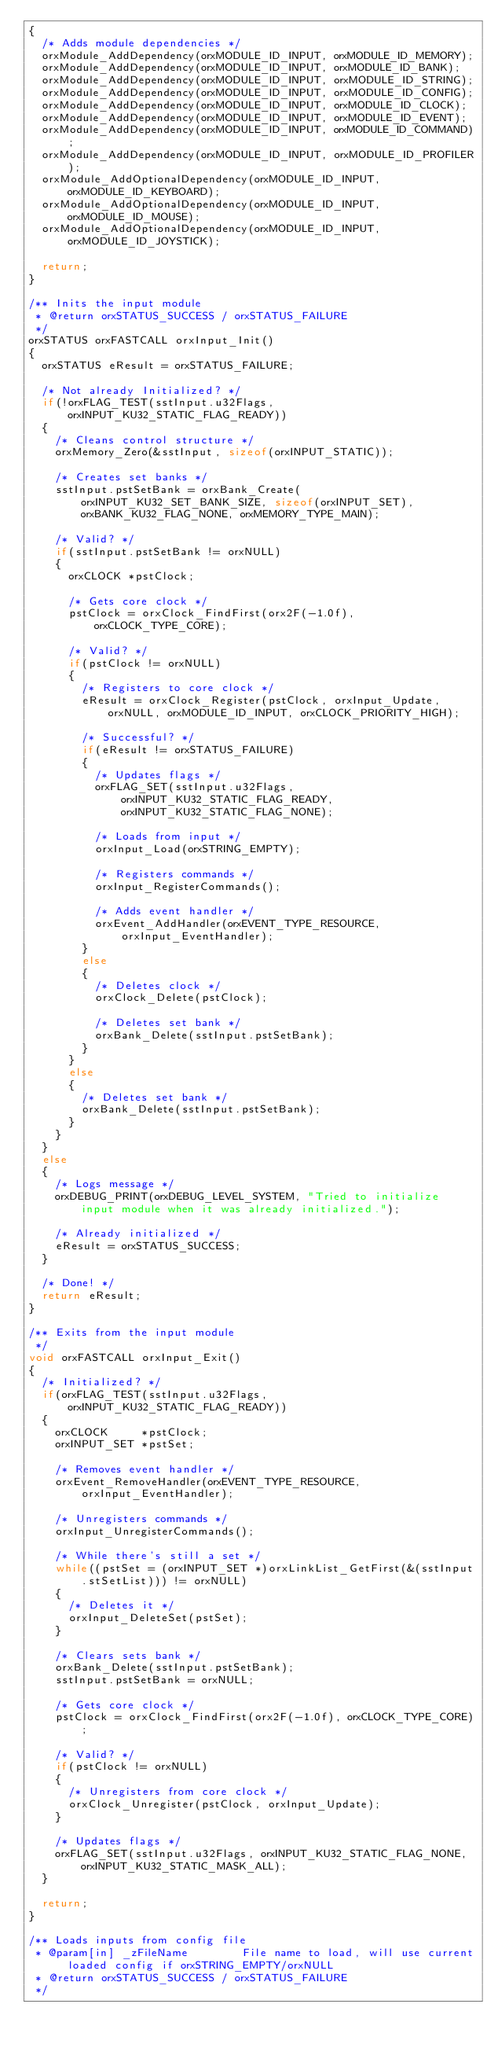Convert code to text. <code><loc_0><loc_0><loc_500><loc_500><_C_>{
  /* Adds module dependencies */
  orxModule_AddDependency(orxMODULE_ID_INPUT, orxMODULE_ID_MEMORY);
  orxModule_AddDependency(orxMODULE_ID_INPUT, orxMODULE_ID_BANK);
  orxModule_AddDependency(orxMODULE_ID_INPUT, orxMODULE_ID_STRING);
  orxModule_AddDependency(orxMODULE_ID_INPUT, orxMODULE_ID_CONFIG);
  orxModule_AddDependency(orxMODULE_ID_INPUT, orxMODULE_ID_CLOCK);
  orxModule_AddDependency(orxMODULE_ID_INPUT, orxMODULE_ID_EVENT);
  orxModule_AddDependency(orxMODULE_ID_INPUT, orxMODULE_ID_COMMAND);
  orxModule_AddDependency(orxMODULE_ID_INPUT, orxMODULE_ID_PROFILER);
  orxModule_AddOptionalDependency(orxMODULE_ID_INPUT, orxMODULE_ID_KEYBOARD);
  orxModule_AddOptionalDependency(orxMODULE_ID_INPUT, orxMODULE_ID_MOUSE);
  orxModule_AddOptionalDependency(orxMODULE_ID_INPUT, orxMODULE_ID_JOYSTICK);

  return;
}

/** Inits the input module
 * @return orxSTATUS_SUCCESS / orxSTATUS_FAILURE
 */
orxSTATUS orxFASTCALL orxInput_Init()
{
  orxSTATUS eResult = orxSTATUS_FAILURE;

  /* Not already Initialized? */
  if(!orxFLAG_TEST(sstInput.u32Flags, orxINPUT_KU32_STATIC_FLAG_READY))
  {
    /* Cleans control structure */
    orxMemory_Zero(&sstInput, sizeof(orxINPUT_STATIC));

    /* Creates set banks */
    sstInput.pstSetBank = orxBank_Create(orxINPUT_KU32_SET_BANK_SIZE, sizeof(orxINPUT_SET), orxBANK_KU32_FLAG_NONE, orxMEMORY_TYPE_MAIN);

    /* Valid? */
    if(sstInput.pstSetBank != orxNULL)
    {
      orxCLOCK *pstClock;

      /* Gets core clock */
      pstClock = orxClock_FindFirst(orx2F(-1.0f), orxCLOCK_TYPE_CORE);

      /* Valid? */
      if(pstClock != orxNULL)
      {
        /* Registers to core clock */
        eResult = orxClock_Register(pstClock, orxInput_Update, orxNULL, orxMODULE_ID_INPUT, orxCLOCK_PRIORITY_HIGH);

        /* Successful? */
        if(eResult != orxSTATUS_FAILURE)
        {
          /* Updates flags */
          orxFLAG_SET(sstInput.u32Flags, orxINPUT_KU32_STATIC_FLAG_READY, orxINPUT_KU32_STATIC_FLAG_NONE);

          /* Loads from input */
          orxInput_Load(orxSTRING_EMPTY);

          /* Registers commands */
          orxInput_RegisterCommands();

          /* Adds event handler */
          orxEvent_AddHandler(orxEVENT_TYPE_RESOURCE, orxInput_EventHandler);
        }
        else
        {
          /* Deletes clock */
          orxClock_Delete(pstClock);

          /* Deletes set bank */
          orxBank_Delete(sstInput.pstSetBank);
        }
      }
      else
      {
        /* Deletes set bank */
        orxBank_Delete(sstInput.pstSetBank);
      }
    }
  }
  else
  {
    /* Logs message */
    orxDEBUG_PRINT(orxDEBUG_LEVEL_SYSTEM, "Tried to initialize input module when it was already initialized.");

    /* Already initialized */
    eResult = orxSTATUS_SUCCESS;
  }

  /* Done! */
  return eResult;
}

/** Exits from the input module
 */
void orxFASTCALL orxInput_Exit()
{
  /* Initialized? */
  if(orxFLAG_TEST(sstInput.u32Flags, orxINPUT_KU32_STATIC_FLAG_READY))
  {
    orxCLOCK     *pstClock;
    orxINPUT_SET *pstSet;

    /* Removes event handler */
    orxEvent_RemoveHandler(orxEVENT_TYPE_RESOURCE, orxInput_EventHandler);

    /* Unregisters commands */
    orxInput_UnregisterCommands();

    /* While there's still a set */
    while((pstSet = (orxINPUT_SET *)orxLinkList_GetFirst(&(sstInput.stSetList))) != orxNULL)
    {
      /* Deletes it */
      orxInput_DeleteSet(pstSet);
    }

    /* Clears sets bank */
    orxBank_Delete(sstInput.pstSetBank);
    sstInput.pstSetBank = orxNULL;

    /* Gets core clock */
    pstClock = orxClock_FindFirst(orx2F(-1.0f), orxCLOCK_TYPE_CORE);

    /* Valid? */
    if(pstClock != orxNULL)
    {
      /* Unregisters from core clock */
      orxClock_Unregister(pstClock, orxInput_Update);
    }

    /* Updates flags */
    orxFLAG_SET(sstInput.u32Flags, orxINPUT_KU32_STATIC_FLAG_NONE, orxINPUT_KU32_STATIC_MASK_ALL);
  }

  return;
}

/** Loads inputs from config file
 * @param[in] _zFileName        File name to load, will use current loaded config if orxSTRING_EMPTY/orxNULL
 * @return orxSTATUS_SUCCESS / orxSTATUS_FAILURE
 */</code> 